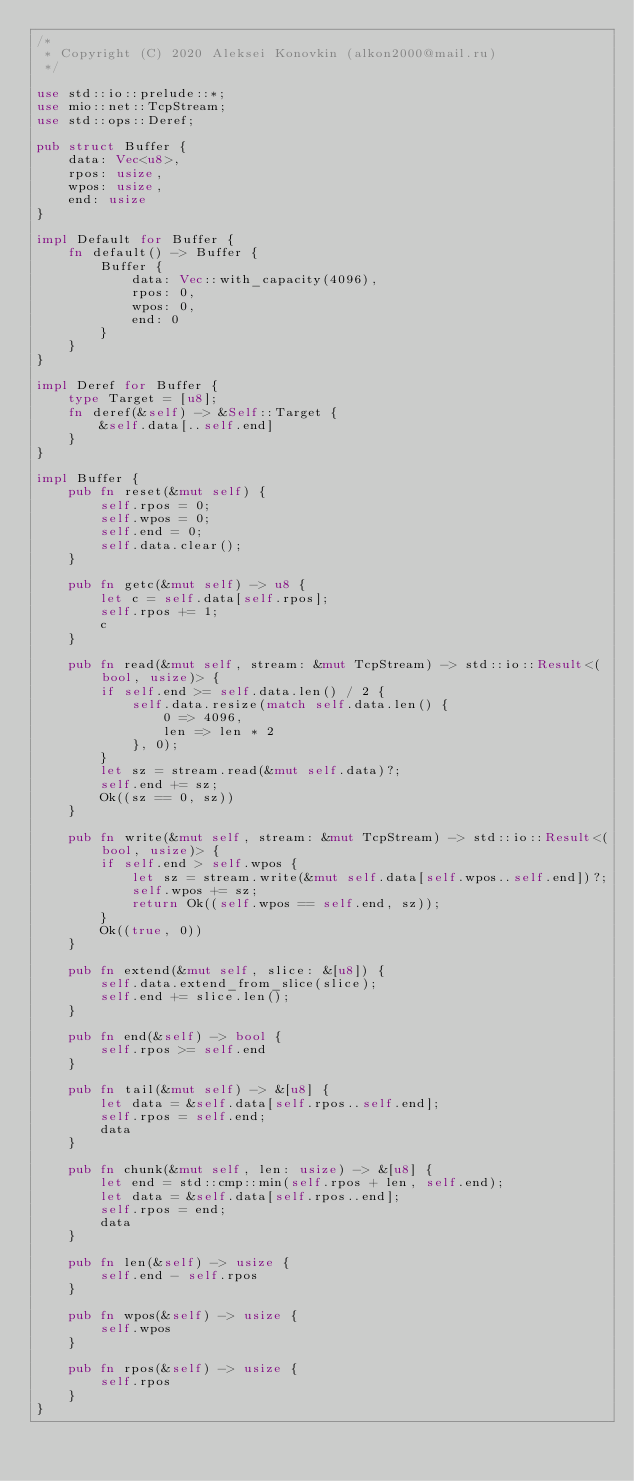Convert code to text. <code><loc_0><loc_0><loc_500><loc_500><_Rust_>/*
 * Copyright (C) 2020 Aleksei Konovkin (alkon2000@mail.ru)
 */

use std::io::prelude::*;
use mio::net::TcpStream;
use std::ops::Deref;

pub struct Buffer {
    data: Vec<u8>,
    rpos: usize,
    wpos: usize,
    end: usize
}

impl Default for Buffer {
    fn default() -> Buffer {
        Buffer {
            data: Vec::with_capacity(4096),
            rpos: 0,
            wpos: 0,
            end: 0
        }
    }
}

impl Deref for Buffer {
    type Target = [u8];
    fn deref(&self) -> &Self::Target {
        &self.data[..self.end]
    }
}

impl Buffer {
    pub fn reset(&mut self) {
        self.rpos = 0;
        self.wpos = 0;
        self.end = 0;
        self.data.clear();
    }

    pub fn getc(&mut self) -> u8 {
        let c = self.data[self.rpos];
        self.rpos += 1;
        c
    }

    pub fn read(&mut self, stream: &mut TcpStream) -> std::io::Result<(bool, usize)> {
        if self.end >= self.data.len() / 2 {
            self.data.resize(match self.data.len() {
                0 => 4096,
                len => len * 2
            }, 0);
        }
        let sz = stream.read(&mut self.data)?;
        self.end += sz;
        Ok((sz == 0, sz))
    }

    pub fn write(&mut self, stream: &mut TcpStream) -> std::io::Result<(bool, usize)> {
        if self.end > self.wpos {
            let sz = stream.write(&mut self.data[self.wpos..self.end])?;
            self.wpos += sz;
            return Ok((self.wpos == self.end, sz));
        }
        Ok((true, 0))
    }

    pub fn extend(&mut self, slice: &[u8]) {
        self.data.extend_from_slice(slice);
        self.end += slice.len();
    }

    pub fn end(&self) -> bool {
        self.rpos >= self.end
    }

    pub fn tail(&mut self) -> &[u8] {
        let data = &self.data[self.rpos..self.end];
        self.rpos = self.end;
        data
    }

    pub fn chunk(&mut self, len: usize) -> &[u8] {
        let end = std::cmp::min(self.rpos + len, self.end);
        let data = &self.data[self.rpos..end];
        self.rpos = end;
        data
    }

    pub fn len(&self) -> usize {
        self.end - self.rpos
    }

    pub fn wpos(&self) -> usize {
        self.wpos
    }

    pub fn rpos(&self) -> usize {
        self.rpos
    }
}
</code> 